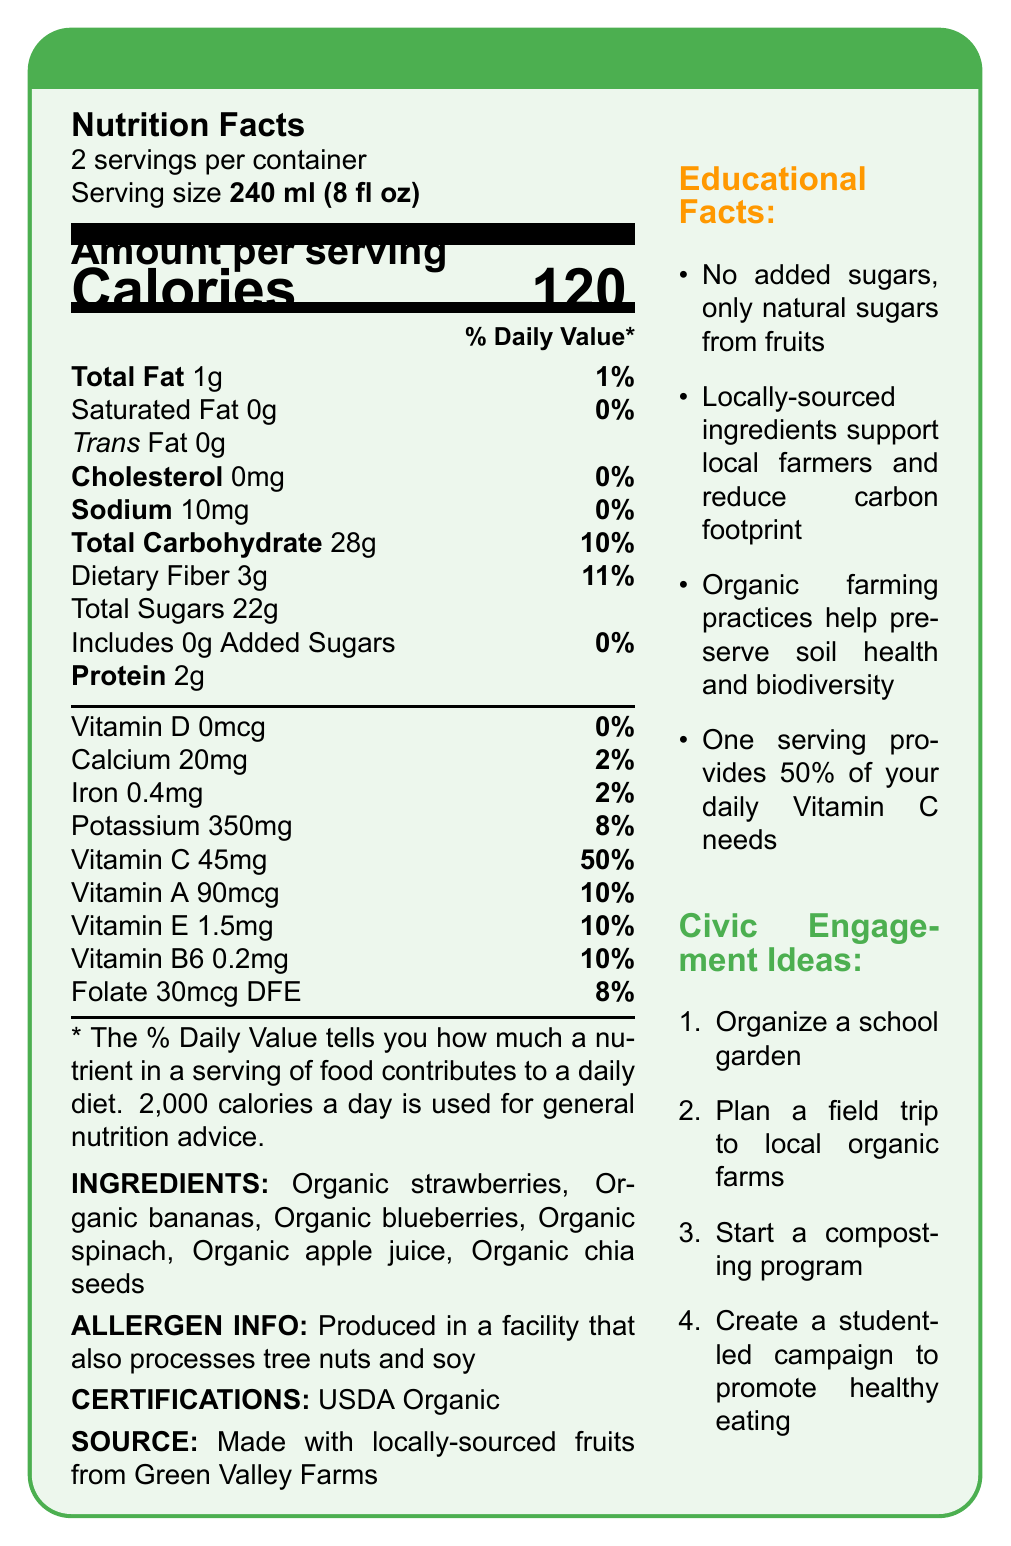what is the serving size of the smoothie? The serving size is stated clearly under the Nutrition Facts section as "Serving size 240 ml (8 fl oz)".
Answer: 240 ml (8 fl oz) how many calories are in one serving? The calorie content per serving is displayed prominently under "Amount per serving" with the label "Calories 120".
Answer: 120 what percentage of the daily value of fiber does one serving provide? Under the "Total Carbohydrate" section, "Dietary Fiber 3g" is given with "11%" as the daily value.
Answer: 11% does the smoothie contain any added sugars? The document lists "Includes 0g Added Sugars" under "Total Sugars".
Answer: No name three vitamins present in the smoothie along with their daily values. The vitamins and their daily values are listed in the "Vitamin" section.
Answer: Vitamin C - 50%, Vitamin A - 10%, Vitamin E - 10% which ingredient in the smoothie is not a fruit? A. Organic strawberries B. Organic chia seeds C. Organic blueberries D. Organic bananas The ingredients listed include fruits like strawberries, blueberries, bananas, but chia seeds are not a fruit.
Answer: B how much protein does one serving of the smoothie contain? A. 1g B. 2g C. 3g D. 4g The Protein content per serving is listed as "2g".
Answer: B does the smoothie contain any cholesterol? The Cholesterol content is listed under its own section as "0mg" with a daily value of "0%".
Answer: No summarize the main idea of the document in one sentence. The document contains various sections providing detailed information about the smoothie, including its nutritional value, ingredients, and other facts promoting local sourcing and organic practices.
Answer: The document provides the nutritional information, ingredients, allergen info, certifications, educational facts, and civic engagement ideas regarding the Garden Fresh Organic Fruit Smoothie. can the percentage of Vitamin D in one serving be found in the document? The percentage of Vitamin D is given as "0%" under the "Vitamin D" section.
Answer: Yes calculate the total calories if someone consumes the entire container. Since there are 2 servings per container and each serving contains 120 calories, consuming both servings would result in 240 calories (120 calories/serving × 2 servings/container).
Answer: 240 calories where are the ingredients of the smoothie sourced from? The source information is provided at the bottom of the document, stating that the ingredients are from Green Valley Farms.
Answer: Green Valley Farms what is one civic engagement idea listed in the document? One of the civic engagement ideas noted on the right side of the document is to organize a school garden.
Answer: Organize a school garden. can you determine the price of the smoothie from the document? The document does not provide any details about the price of the smoothie.
Answer: Not enough information 